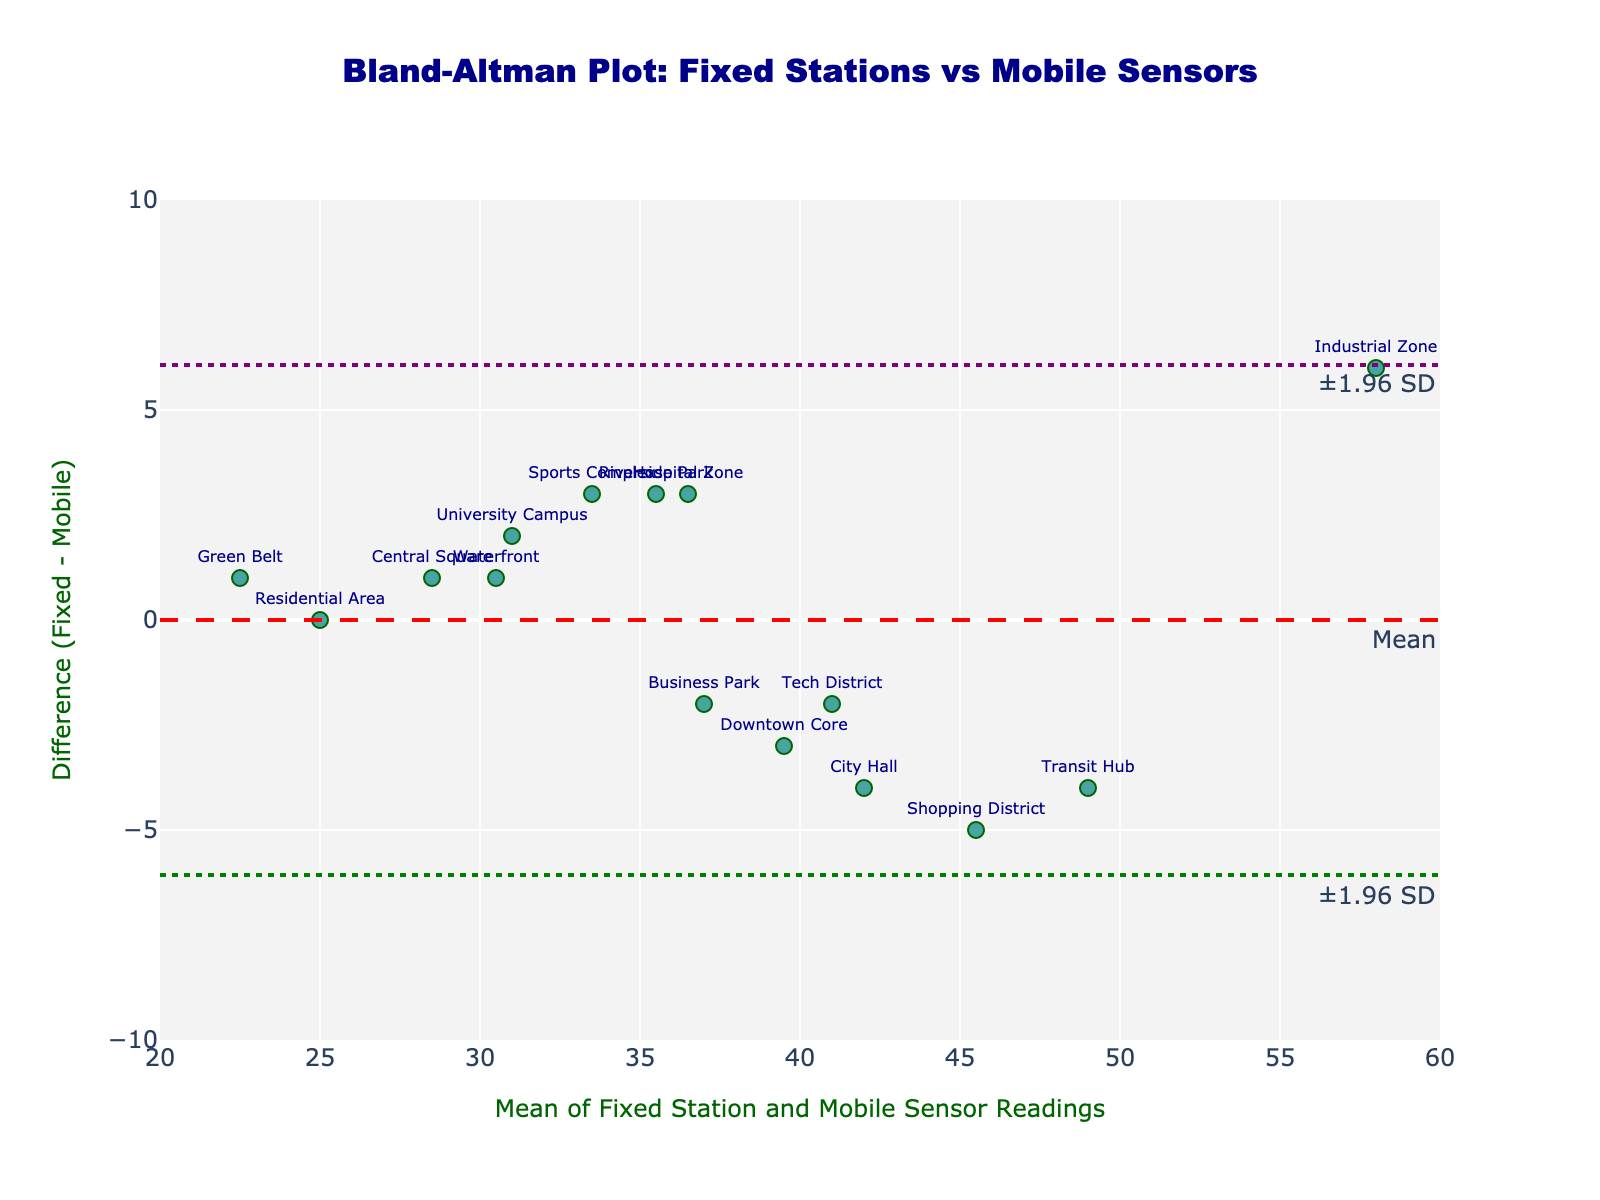What is the main title of the plot? The title is placed at the top center of the plot. The text reads, "Bland-Altman Plot: Fixed Stations vs Mobile Sensors".
Answer: Bland-Altman Plot: Fixed Stations vs Mobile Sensors How many data points are represented in the plot? Each marker in the plot represents a data point. To find the number of data points, count the individual markers.
Answer: 15 What is the y-coordinate of the mean line in the plot? The mean line is labeled "Mean" and is a dashed red line. Its y-coordinate is determined by the mean difference of the data points.
Answer: 0.6 What is the range of the x-axis? The x-axis represents the "Mean of Fixed Station and Mobile Sensor Readings" and the range can be identified by looking at the ends of the axis.
Answer: 20 to 60 Which data point has the highest difference value? To find the highest difference value, identify the point that is highest on the y-axis. The text label of the point will indicate its identity.
Answer: Industrial Zone What are the upper and lower limits of agreement in the plot? The limits of agreement are represented by the two dotted lines, one above and one below the mean line. The y-coordinates of these lines represent the limits.
Answer: 6.8 and -5.6 Comparing Riverside Park and University Campus, which has a larger air quality reading difference? Riverside Park and University Campus can be identified by their text labels. Compare their y-coordinates to determine which has the larger absolute difference.
Answer: Riverside Park What is the y-coordinate of the Residential Area data point? The y-coordinate of the Residential Area can be found by locating its text label and identifying its position on the y-axis.
Answer: 0 What colors are used for the dotted limit lines? The dotted limit lines on the plot are visually distinguishable by their colors. Identify the colors of these lines.
Answer: Green and Purple Between the Transit Hub and Shopping District, which location has a larger negative difference? Transit Hub and Shopping District can be identified by their text labels. Compare their y-coordinates to determine which has the larger negative value.
Answer: Shopping District 